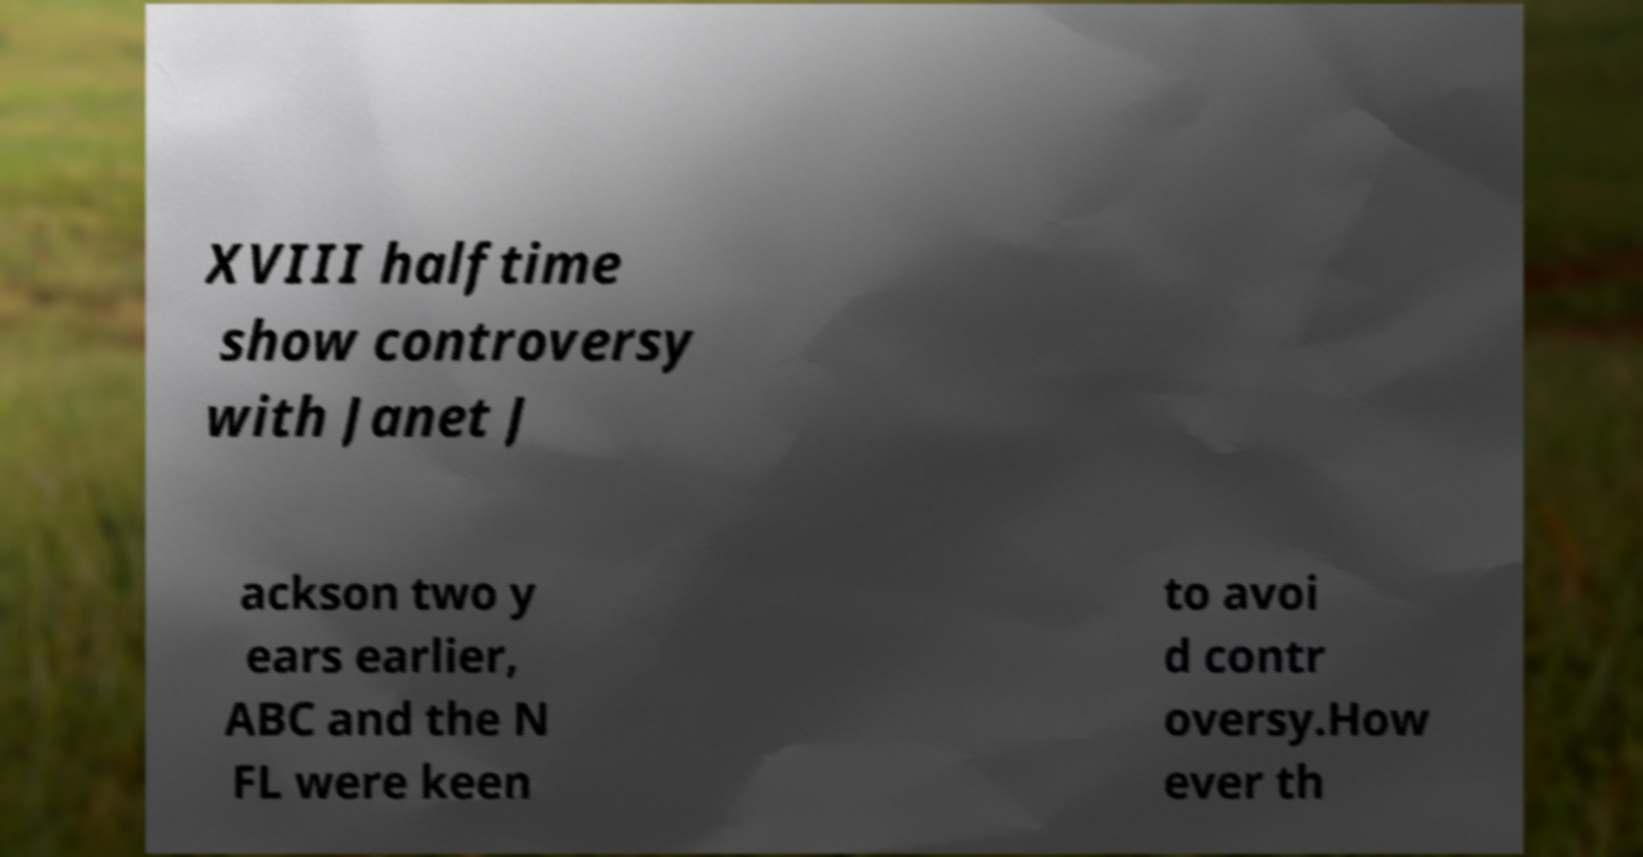What messages or text are displayed in this image? I need them in a readable, typed format. XVIII halftime show controversy with Janet J ackson two y ears earlier, ABC and the N FL were keen to avoi d contr oversy.How ever th 